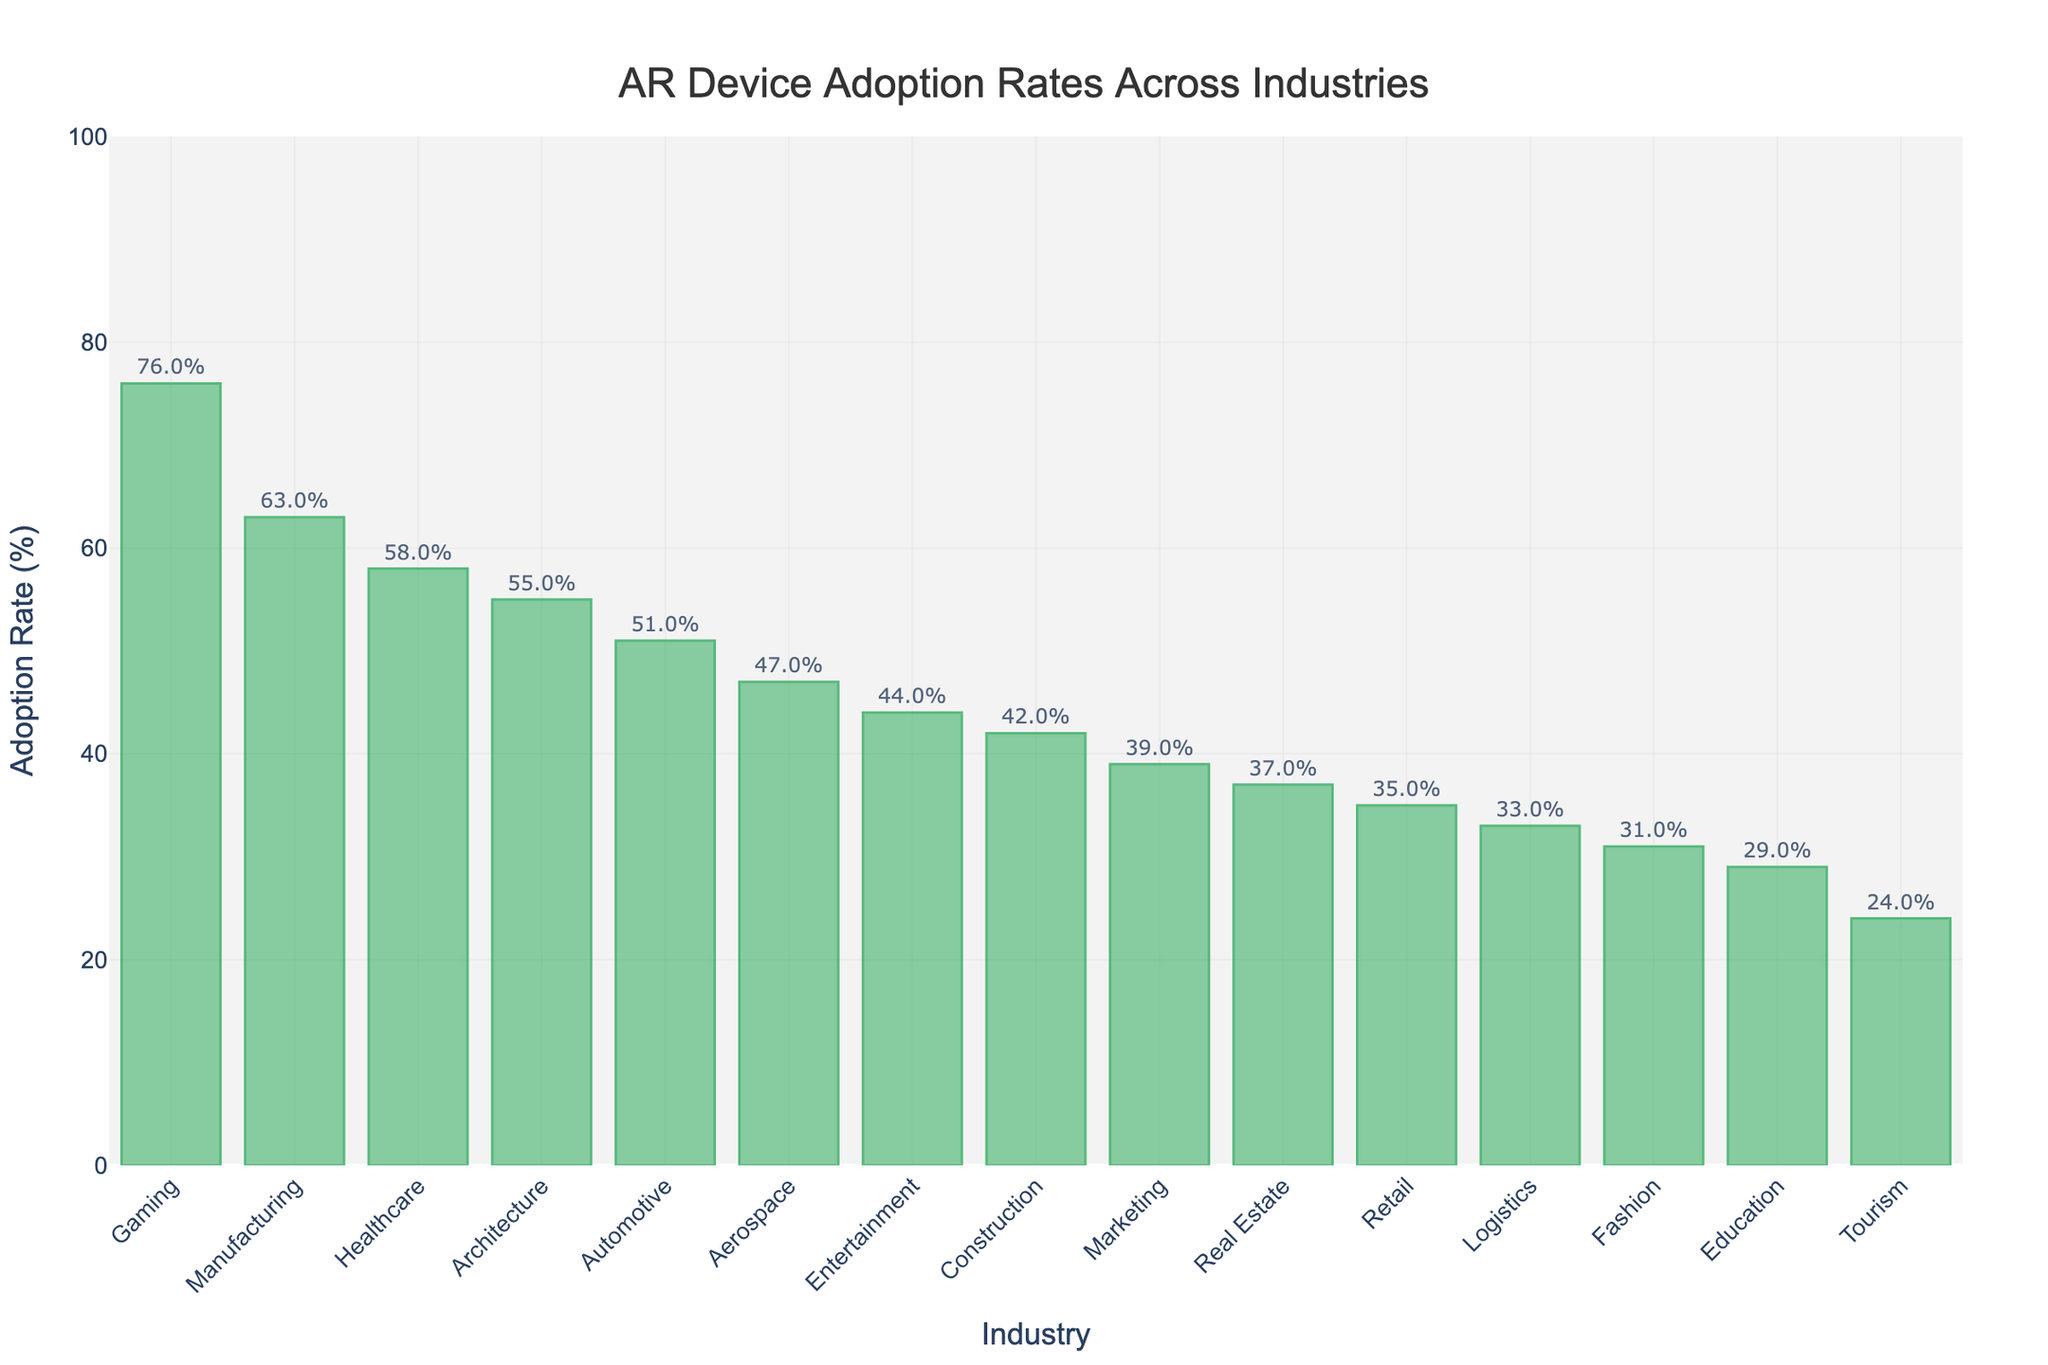What's the industry with the highest AR device adoption rate? The highest bar in the chart represents the industry with the highest adoption rate. In this case, 'Gaming' has the tallest bar.
Answer: Gaming What's the difference in AR device adoption rates between the Gaming and Tourism industries? The adoption rate for Gaming is 76% and for Tourism is 24%. The difference is calculated by subtracting the smaller value from the larger value: 76% - 24% = 52%.
Answer: 52% Which industries have AR device adoption rates above 50%? The bars that surpass the 50% mark on the y-axis represent industries with adoption rates above 50%. These industries are Gaming, Manufacturing, Healthcare, Automotive, and Architecture.
Answer: Gaming, Manufacturing, Healthcare, Automotive, Architecture What's the average AR device adoption rate across all industries shown? To find the average, sum all the adoption rates and divide by the number of industries. The sum is 729 and there are 15 industries, so the average is 729/15 = 48.6%.
Answer: 48.6% What is the median AR device adoption rate among all industries? To find the median, first list the rates in ascending order: 24, 29, 31, 33, 35, 37, 39, 42, 44, 47, 51, 55, 58, 63, 76. The median is the middle value, which is 42.
Answer: 42 How many industries have an AR device adoption rate below the median rate of 42%? The median rate is 42%. Count the number of industries with rates below 42%, which are: Tourism, Education, Fashion, Logistics, Retail, Real Estate, and Marketing. There are 7 industries in total.
Answer: 7 Which industry has a higher AR device adoption rate: Aerospace or Fashion? Compare the heights of the bars for Aerospace and Fashion. Aerospace has a rate of 47% and Fashion has 31%. Aerospace is higher.
Answer: Aerospace Are the majority of industries above or below the mean adoption rate of 48.6%? By counting the number of industries above and below the mean rate (48.6%), we find: Below mean: 9 (Tourism, Education, Fashion, Logistics, Retail, Real Estate, Marketing, Construction, Entertainment), Above mean: 6 (Aerospace, Automotive, Architecture, Healthcare, Manufacturing, Gaming). The majority are below.
Answer: Below What is the total AR device adoption rate for the top 3 industries? The top 3 industries are Gaming (76%), Manufacturing (63%), and Healthcare (58%). Summing these rates: 76 + 63 + 58 = 197.
Answer: 197 How does the adoption rate in Entertainment compare to Marketing and Real Estate? The rates for Entertainment, Marketing, and Real Estate are 44%, 39%, and 37% respectively. Entertainment has the highest, followed by Marketing, then Real Estate.
Answer: Entertainment > Marketing > Real Estate 